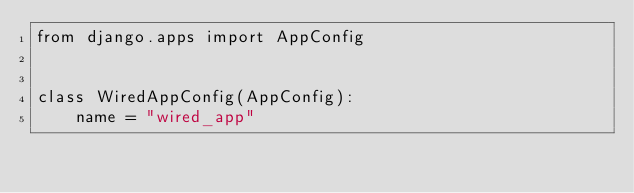<code> <loc_0><loc_0><loc_500><loc_500><_Python_>from django.apps import AppConfig


class WiredAppConfig(AppConfig):
    name = "wired_app"
</code> 